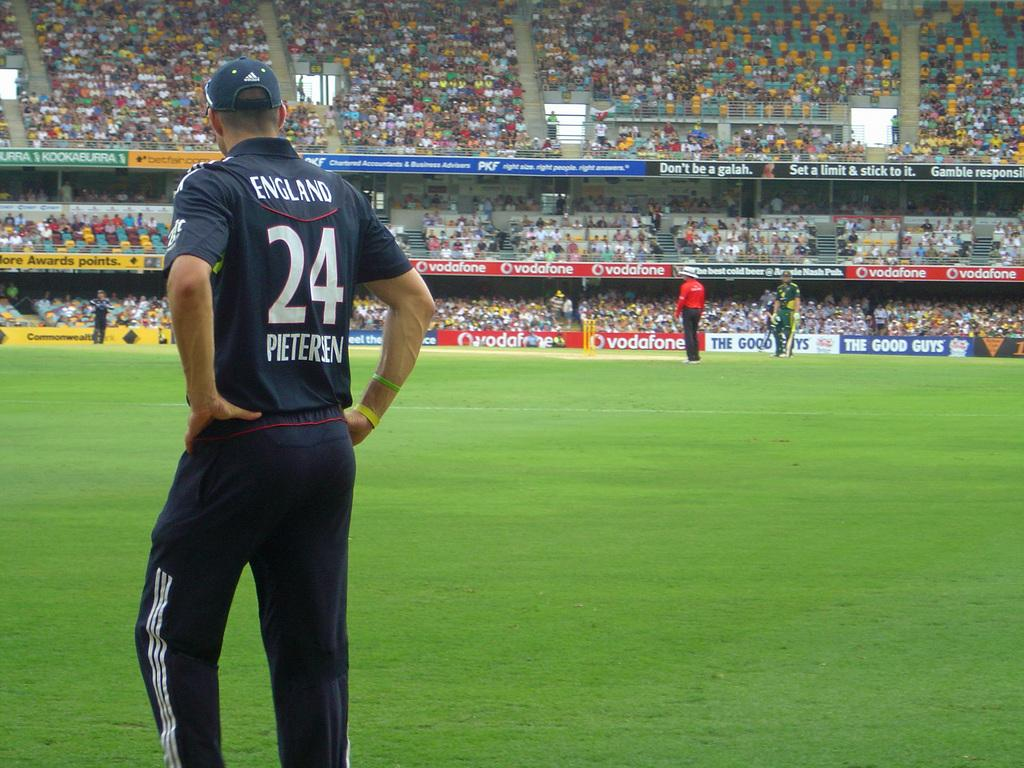<image>
Provide a brief description of the given image. A player for England named Pieteren is standing on a soccer field. 